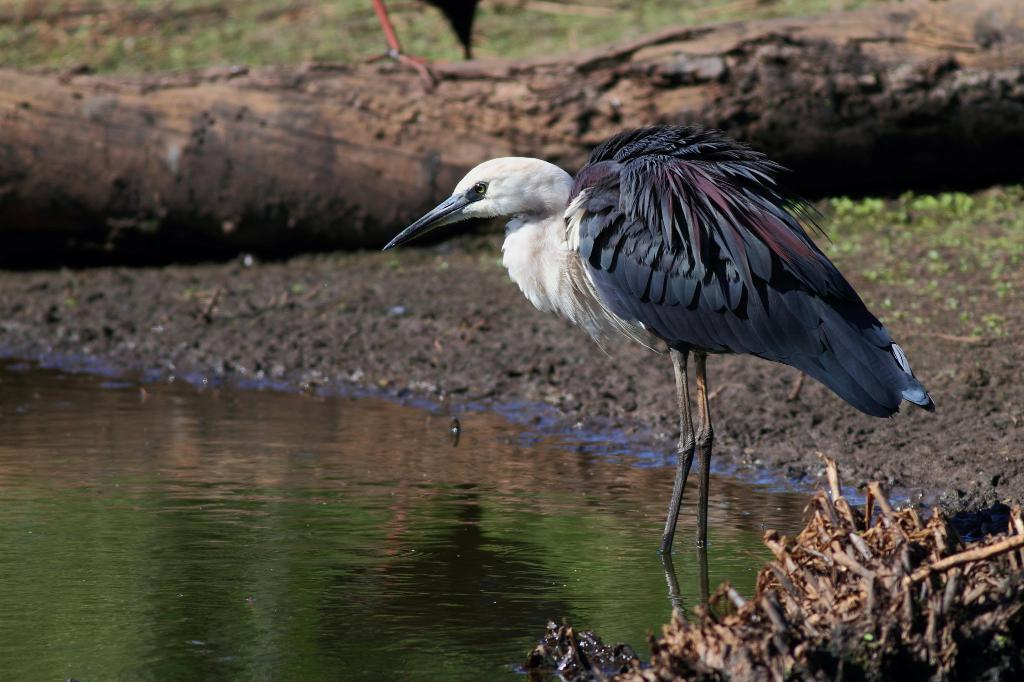What is the main subject of the image? The main subject of the image is a crane. Where is the crane located in the image? The crane is standing in the water. What is the color of the crane? The crane is black in color. What can be seen on the left side of the image? There is water on the left side of the image. What is in the middle of the image? There is a log in the middle of the image. What type of car is the crane's daughter driving in the image? There is no car or daughter present in the image; it features a black crane standing in the water. How is the string used in the image? There is no string present in the image. 